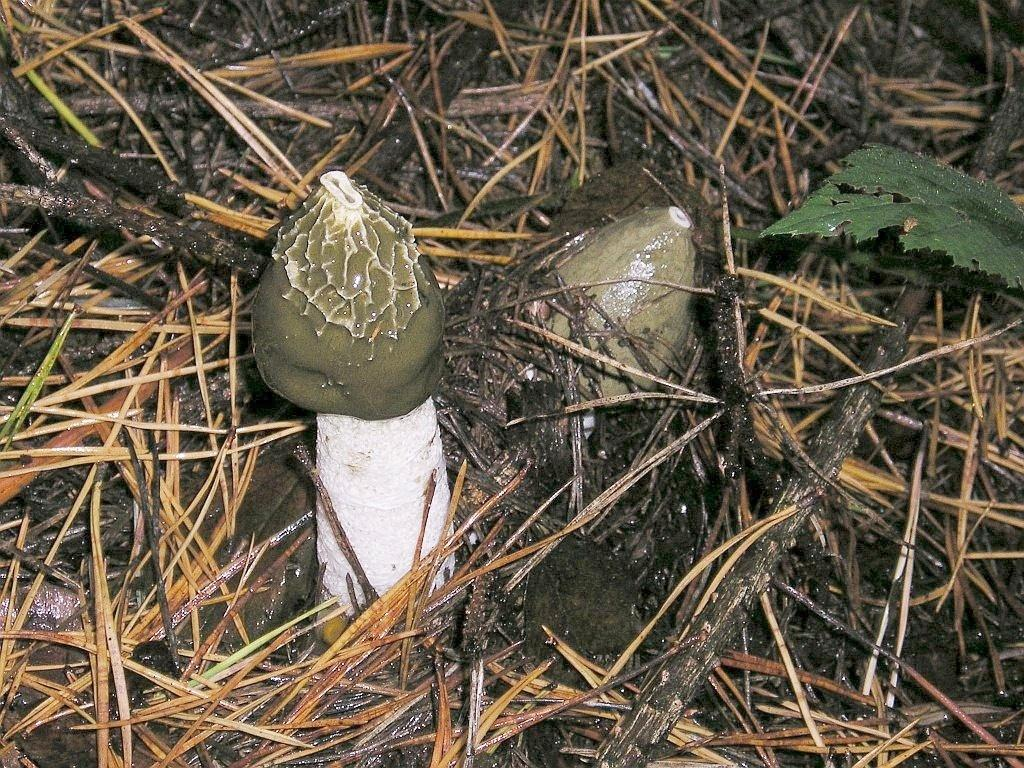What type of fungi can be seen in the image? There are mushrooms in the image. What type of plant material is present in the image? There is a leaf in the image. What is the texture of the ground in the image? Dry grass is visible in the image. What type of soil can be seen in the image? There is mud in the image. Where is the desk located in the image? There is no desk present in the image. What type of crowd can be seen in the image? There is no crowd present in the image. 